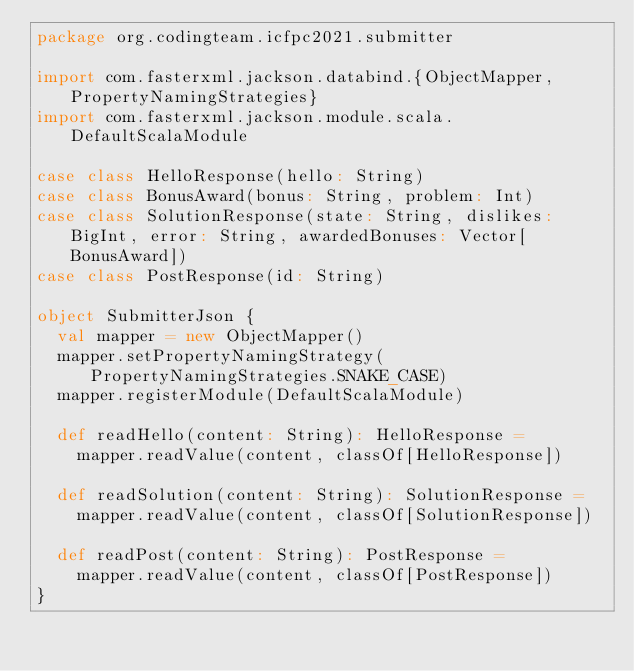<code> <loc_0><loc_0><loc_500><loc_500><_Scala_>package org.codingteam.icfpc2021.submitter

import com.fasterxml.jackson.databind.{ObjectMapper, PropertyNamingStrategies}
import com.fasterxml.jackson.module.scala.DefaultScalaModule

case class HelloResponse(hello: String)
case class BonusAward(bonus: String, problem: Int)
case class SolutionResponse(state: String, dislikes: BigInt, error: String, awardedBonuses: Vector[BonusAward])
case class PostResponse(id: String)

object SubmitterJson {
  val mapper = new ObjectMapper()
  mapper.setPropertyNamingStrategy(PropertyNamingStrategies.SNAKE_CASE)
  mapper.registerModule(DefaultScalaModule)

  def readHello(content: String): HelloResponse =
    mapper.readValue(content, classOf[HelloResponse])

  def readSolution(content: String): SolutionResponse =
    mapper.readValue(content, classOf[SolutionResponse])

  def readPost(content: String): PostResponse =
    mapper.readValue(content, classOf[PostResponse])
}
</code> 